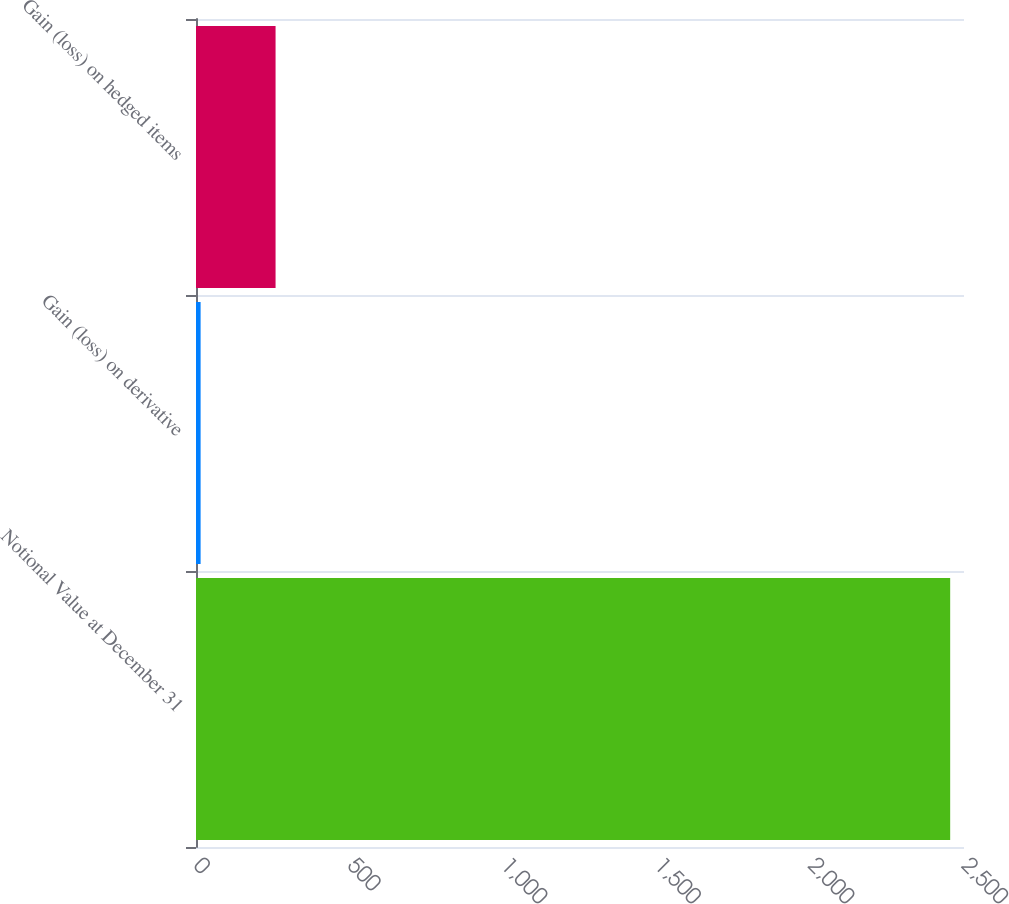Convert chart to OTSL. <chart><loc_0><loc_0><loc_500><loc_500><bar_chart><fcel>Notional Value at December 31<fcel>Gain (loss) on derivative<fcel>Gain (loss) on hedged items<nl><fcel>2455<fcel>15<fcel>259<nl></chart> 